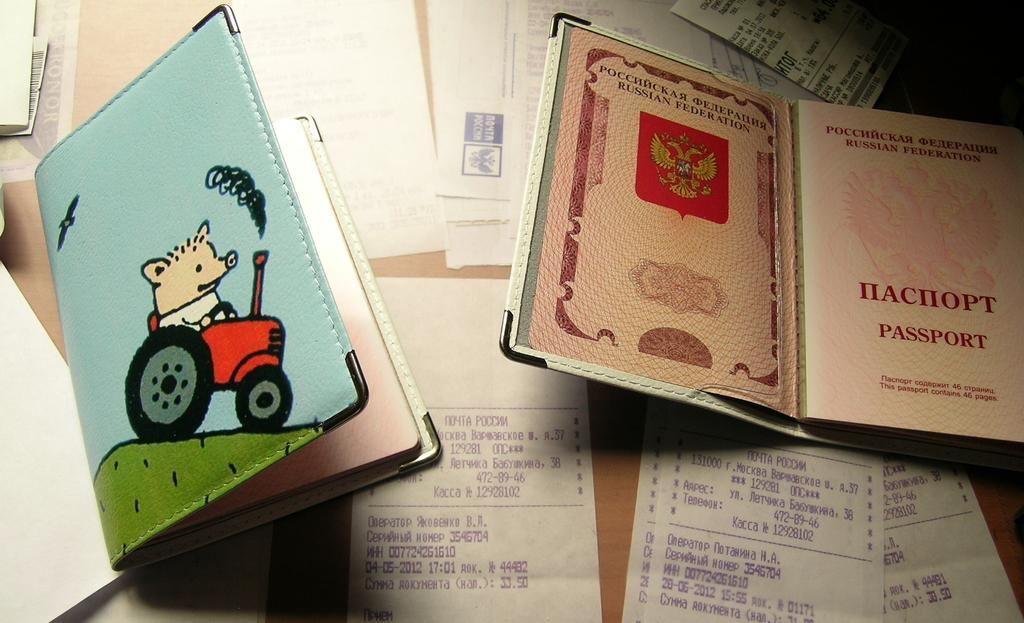Provide a one-sentence caption for the provided image. A passport cover is open, showing the word "passport" on the first page. 